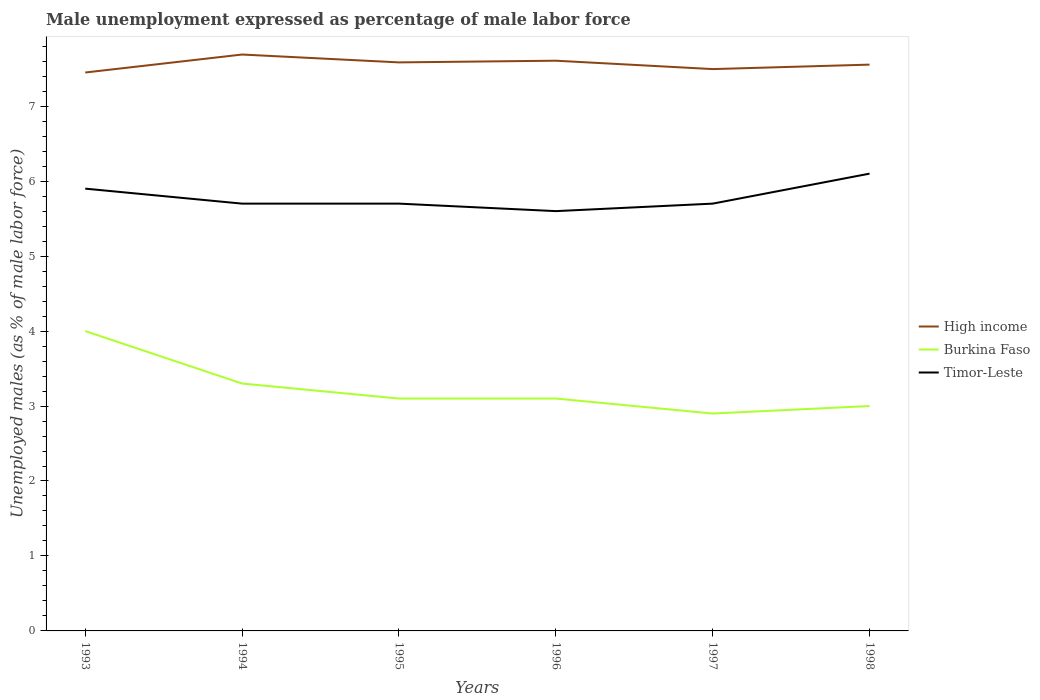How many different coloured lines are there?
Provide a short and direct response. 3. Across all years, what is the maximum unemployment in males in in High income?
Ensure brevity in your answer.  7.45. What is the total unemployment in males in in Timor-Leste in the graph?
Offer a very short reply. 0.3. What is the difference between the highest and the second highest unemployment in males in in Timor-Leste?
Provide a short and direct response. 0.5. Is the unemployment in males in in Burkina Faso strictly greater than the unemployment in males in in High income over the years?
Ensure brevity in your answer.  Yes. What is the title of the graph?
Make the answer very short. Male unemployment expressed as percentage of male labor force. Does "Australia" appear as one of the legend labels in the graph?
Provide a succinct answer. No. What is the label or title of the Y-axis?
Your answer should be very brief. Unemployed males (as % of male labor force). What is the Unemployed males (as % of male labor force) in High income in 1993?
Offer a terse response. 7.45. What is the Unemployed males (as % of male labor force) of Timor-Leste in 1993?
Your answer should be compact. 5.9. What is the Unemployed males (as % of male labor force) in High income in 1994?
Keep it short and to the point. 7.69. What is the Unemployed males (as % of male labor force) of Burkina Faso in 1994?
Give a very brief answer. 3.3. What is the Unemployed males (as % of male labor force) of Timor-Leste in 1994?
Your response must be concise. 5.7. What is the Unemployed males (as % of male labor force) of High income in 1995?
Your answer should be very brief. 7.58. What is the Unemployed males (as % of male labor force) of Burkina Faso in 1995?
Give a very brief answer. 3.1. What is the Unemployed males (as % of male labor force) of Timor-Leste in 1995?
Keep it short and to the point. 5.7. What is the Unemployed males (as % of male labor force) in High income in 1996?
Offer a very short reply. 7.61. What is the Unemployed males (as % of male labor force) in Burkina Faso in 1996?
Give a very brief answer. 3.1. What is the Unemployed males (as % of male labor force) in Timor-Leste in 1996?
Your answer should be compact. 5.6. What is the Unemployed males (as % of male labor force) of High income in 1997?
Ensure brevity in your answer.  7.49. What is the Unemployed males (as % of male labor force) in Burkina Faso in 1997?
Provide a succinct answer. 2.9. What is the Unemployed males (as % of male labor force) in Timor-Leste in 1997?
Ensure brevity in your answer.  5.7. What is the Unemployed males (as % of male labor force) of High income in 1998?
Offer a terse response. 7.55. What is the Unemployed males (as % of male labor force) in Timor-Leste in 1998?
Provide a succinct answer. 6.1. Across all years, what is the maximum Unemployed males (as % of male labor force) in High income?
Give a very brief answer. 7.69. Across all years, what is the maximum Unemployed males (as % of male labor force) in Burkina Faso?
Keep it short and to the point. 4. Across all years, what is the maximum Unemployed males (as % of male labor force) of Timor-Leste?
Keep it short and to the point. 6.1. Across all years, what is the minimum Unemployed males (as % of male labor force) in High income?
Give a very brief answer. 7.45. Across all years, what is the minimum Unemployed males (as % of male labor force) of Burkina Faso?
Keep it short and to the point. 2.9. Across all years, what is the minimum Unemployed males (as % of male labor force) of Timor-Leste?
Provide a succinct answer. 5.6. What is the total Unemployed males (as % of male labor force) in High income in the graph?
Provide a succinct answer. 45.38. What is the total Unemployed males (as % of male labor force) of Burkina Faso in the graph?
Make the answer very short. 19.4. What is the total Unemployed males (as % of male labor force) of Timor-Leste in the graph?
Your response must be concise. 34.7. What is the difference between the Unemployed males (as % of male labor force) of High income in 1993 and that in 1994?
Ensure brevity in your answer.  -0.24. What is the difference between the Unemployed males (as % of male labor force) in High income in 1993 and that in 1995?
Offer a very short reply. -0.14. What is the difference between the Unemployed males (as % of male labor force) in Burkina Faso in 1993 and that in 1995?
Offer a very short reply. 0.9. What is the difference between the Unemployed males (as % of male labor force) of Timor-Leste in 1993 and that in 1995?
Keep it short and to the point. 0.2. What is the difference between the Unemployed males (as % of male labor force) of High income in 1993 and that in 1996?
Provide a succinct answer. -0.16. What is the difference between the Unemployed males (as % of male labor force) of Burkina Faso in 1993 and that in 1996?
Give a very brief answer. 0.9. What is the difference between the Unemployed males (as % of male labor force) in High income in 1993 and that in 1997?
Your answer should be very brief. -0.05. What is the difference between the Unemployed males (as % of male labor force) of High income in 1993 and that in 1998?
Provide a succinct answer. -0.11. What is the difference between the Unemployed males (as % of male labor force) in High income in 1994 and that in 1995?
Keep it short and to the point. 0.1. What is the difference between the Unemployed males (as % of male labor force) in Timor-Leste in 1994 and that in 1995?
Keep it short and to the point. 0. What is the difference between the Unemployed males (as % of male labor force) of High income in 1994 and that in 1996?
Your answer should be compact. 0.08. What is the difference between the Unemployed males (as % of male labor force) of Burkina Faso in 1994 and that in 1996?
Your response must be concise. 0.2. What is the difference between the Unemployed males (as % of male labor force) of High income in 1994 and that in 1997?
Provide a succinct answer. 0.19. What is the difference between the Unemployed males (as % of male labor force) of Burkina Faso in 1994 and that in 1997?
Keep it short and to the point. 0.4. What is the difference between the Unemployed males (as % of male labor force) of High income in 1994 and that in 1998?
Offer a very short reply. 0.13. What is the difference between the Unemployed males (as % of male labor force) in High income in 1995 and that in 1996?
Your response must be concise. -0.02. What is the difference between the Unemployed males (as % of male labor force) in Timor-Leste in 1995 and that in 1996?
Your answer should be very brief. 0.1. What is the difference between the Unemployed males (as % of male labor force) of High income in 1995 and that in 1997?
Give a very brief answer. 0.09. What is the difference between the Unemployed males (as % of male labor force) in Timor-Leste in 1995 and that in 1997?
Offer a terse response. 0. What is the difference between the Unemployed males (as % of male labor force) in High income in 1995 and that in 1998?
Provide a short and direct response. 0.03. What is the difference between the Unemployed males (as % of male labor force) of Timor-Leste in 1995 and that in 1998?
Keep it short and to the point. -0.4. What is the difference between the Unemployed males (as % of male labor force) of High income in 1996 and that in 1997?
Your answer should be very brief. 0.11. What is the difference between the Unemployed males (as % of male labor force) in Burkina Faso in 1996 and that in 1997?
Provide a short and direct response. 0.2. What is the difference between the Unemployed males (as % of male labor force) in High income in 1996 and that in 1998?
Provide a short and direct response. 0.05. What is the difference between the Unemployed males (as % of male labor force) of Burkina Faso in 1996 and that in 1998?
Your response must be concise. 0.1. What is the difference between the Unemployed males (as % of male labor force) in High income in 1997 and that in 1998?
Your answer should be very brief. -0.06. What is the difference between the Unemployed males (as % of male labor force) of High income in 1993 and the Unemployed males (as % of male labor force) of Burkina Faso in 1994?
Your answer should be very brief. 4.15. What is the difference between the Unemployed males (as % of male labor force) in High income in 1993 and the Unemployed males (as % of male labor force) in Timor-Leste in 1994?
Ensure brevity in your answer.  1.75. What is the difference between the Unemployed males (as % of male labor force) of High income in 1993 and the Unemployed males (as % of male labor force) of Burkina Faso in 1995?
Your response must be concise. 4.35. What is the difference between the Unemployed males (as % of male labor force) of High income in 1993 and the Unemployed males (as % of male labor force) of Timor-Leste in 1995?
Keep it short and to the point. 1.75. What is the difference between the Unemployed males (as % of male labor force) in Burkina Faso in 1993 and the Unemployed males (as % of male labor force) in Timor-Leste in 1995?
Your response must be concise. -1.7. What is the difference between the Unemployed males (as % of male labor force) of High income in 1993 and the Unemployed males (as % of male labor force) of Burkina Faso in 1996?
Keep it short and to the point. 4.35. What is the difference between the Unemployed males (as % of male labor force) in High income in 1993 and the Unemployed males (as % of male labor force) in Timor-Leste in 1996?
Keep it short and to the point. 1.85. What is the difference between the Unemployed males (as % of male labor force) in Burkina Faso in 1993 and the Unemployed males (as % of male labor force) in Timor-Leste in 1996?
Give a very brief answer. -1.6. What is the difference between the Unemployed males (as % of male labor force) in High income in 1993 and the Unemployed males (as % of male labor force) in Burkina Faso in 1997?
Your answer should be compact. 4.55. What is the difference between the Unemployed males (as % of male labor force) of High income in 1993 and the Unemployed males (as % of male labor force) of Timor-Leste in 1997?
Provide a succinct answer. 1.75. What is the difference between the Unemployed males (as % of male labor force) of Burkina Faso in 1993 and the Unemployed males (as % of male labor force) of Timor-Leste in 1997?
Make the answer very short. -1.7. What is the difference between the Unemployed males (as % of male labor force) of High income in 1993 and the Unemployed males (as % of male labor force) of Burkina Faso in 1998?
Offer a terse response. 4.45. What is the difference between the Unemployed males (as % of male labor force) of High income in 1993 and the Unemployed males (as % of male labor force) of Timor-Leste in 1998?
Offer a terse response. 1.35. What is the difference between the Unemployed males (as % of male labor force) of Burkina Faso in 1993 and the Unemployed males (as % of male labor force) of Timor-Leste in 1998?
Give a very brief answer. -2.1. What is the difference between the Unemployed males (as % of male labor force) of High income in 1994 and the Unemployed males (as % of male labor force) of Burkina Faso in 1995?
Provide a succinct answer. 4.59. What is the difference between the Unemployed males (as % of male labor force) of High income in 1994 and the Unemployed males (as % of male labor force) of Timor-Leste in 1995?
Keep it short and to the point. 1.99. What is the difference between the Unemployed males (as % of male labor force) of High income in 1994 and the Unemployed males (as % of male labor force) of Burkina Faso in 1996?
Your answer should be very brief. 4.59. What is the difference between the Unemployed males (as % of male labor force) in High income in 1994 and the Unemployed males (as % of male labor force) in Timor-Leste in 1996?
Ensure brevity in your answer.  2.09. What is the difference between the Unemployed males (as % of male labor force) of High income in 1994 and the Unemployed males (as % of male labor force) of Burkina Faso in 1997?
Offer a very short reply. 4.79. What is the difference between the Unemployed males (as % of male labor force) in High income in 1994 and the Unemployed males (as % of male labor force) in Timor-Leste in 1997?
Offer a terse response. 1.99. What is the difference between the Unemployed males (as % of male labor force) of Burkina Faso in 1994 and the Unemployed males (as % of male labor force) of Timor-Leste in 1997?
Keep it short and to the point. -2.4. What is the difference between the Unemployed males (as % of male labor force) in High income in 1994 and the Unemployed males (as % of male labor force) in Burkina Faso in 1998?
Make the answer very short. 4.69. What is the difference between the Unemployed males (as % of male labor force) of High income in 1994 and the Unemployed males (as % of male labor force) of Timor-Leste in 1998?
Offer a terse response. 1.59. What is the difference between the Unemployed males (as % of male labor force) of High income in 1995 and the Unemployed males (as % of male labor force) of Burkina Faso in 1996?
Ensure brevity in your answer.  4.48. What is the difference between the Unemployed males (as % of male labor force) of High income in 1995 and the Unemployed males (as % of male labor force) of Timor-Leste in 1996?
Make the answer very short. 1.98. What is the difference between the Unemployed males (as % of male labor force) of Burkina Faso in 1995 and the Unemployed males (as % of male labor force) of Timor-Leste in 1996?
Give a very brief answer. -2.5. What is the difference between the Unemployed males (as % of male labor force) of High income in 1995 and the Unemployed males (as % of male labor force) of Burkina Faso in 1997?
Provide a succinct answer. 4.68. What is the difference between the Unemployed males (as % of male labor force) in High income in 1995 and the Unemployed males (as % of male labor force) in Timor-Leste in 1997?
Provide a succinct answer. 1.88. What is the difference between the Unemployed males (as % of male labor force) of Burkina Faso in 1995 and the Unemployed males (as % of male labor force) of Timor-Leste in 1997?
Your response must be concise. -2.6. What is the difference between the Unemployed males (as % of male labor force) in High income in 1995 and the Unemployed males (as % of male labor force) in Burkina Faso in 1998?
Make the answer very short. 4.58. What is the difference between the Unemployed males (as % of male labor force) of High income in 1995 and the Unemployed males (as % of male labor force) of Timor-Leste in 1998?
Your answer should be very brief. 1.48. What is the difference between the Unemployed males (as % of male labor force) in Burkina Faso in 1995 and the Unemployed males (as % of male labor force) in Timor-Leste in 1998?
Your answer should be compact. -3. What is the difference between the Unemployed males (as % of male labor force) of High income in 1996 and the Unemployed males (as % of male labor force) of Burkina Faso in 1997?
Make the answer very short. 4.71. What is the difference between the Unemployed males (as % of male labor force) of High income in 1996 and the Unemployed males (as % of male labor force) of Timor-Leste in 1997?
Provide a succinct answer. 1.91. What is the difference between the Unemployed males (as % of male labor force) in High income in 1996 and the Unemployed males (as % of male labor force) in Burkina Faso in 1998?
Make the answer very short. 4.61. What is the difference between the Unemployed males (as % of male labor force) of High income in 1996 and the Unemployed males (as % of male labor force) of Timor-Leste in 1998?
Your response must be concise. 1.51. What is the difference between the Unemployed males (as % of male labor force) of High income in 1997 and the Unemployed males (as % of male labor force) of Burkina Faso in 1998?
Provide a short and direct response. 4.49. What is the difference between the Unemployed males (as % of male labor force) in High income in 1997 and the Unemployed males (as % of male labor force) in Timor-Leste in 1998?
Give a very brief answer. 1.39. What is the difference between the Unemployed males (as % of male labor force) of Burkina Faso in 1997 and the Unemployed males (as % of male labor force) of Timor-Leste in 1998?
Ensure brevity in your answer.  -3.2. What is the average Unemployed males (as % of male labor force) of High income per year?
Make the answer very short. 7.56. What is the average Unemployed males (as % of male labor force) in Burkina Faso per year?
Make the answer very short. 3.23. What is the average Unemployed males (as % of male labor force) in Timor-Leste per year?
Keep it short and to the point. 5.78. In the year 1993, what is the difference between the Unemployed males (as % of male labor force) in High income and Unemployed males (as % of male labor force) in Burkina Faso?
Keep it short and to the point. 3.45. In the year 1993, what is the difference between the Unemployed males (as % of male labor force) of High income and Unemployed males (as % of male labor force) of Timor-Leste?
Your answer should be compact. 1.55. In the year 1993, what is the difference between the Unemployed males (as % of male labor force) of Burkina Faso and Unemployed males (as % of male labor force) of Timor-Leste?
Make the answer very short. -1.9. In the year 1994, what is the difference between the Unemployed males (as % of male labor force) in High income and Unemployed males (as % of male labor force) in Burkina Faso?
Make the answer very short. 4.39. In the year 1994, what is the difference between the Unemployed males (as % of male labor force) of High income and Unemployed males (as % of male labor force) of Timor-Leste?
Keep it short and to the point. 1.99. In the year 1994, what is the difference between the Unemployed males (as % of male labor force) in Burkina Faso and Unemployed males (as % of male labor force) in Timor-Leste?
Provide a succinct answer. -2.4. In the year 1995, what is the difference between the Unemployed males (as % of male labor force) in High income and Unemployed males (as % of male labor force) in Burkina Faso?
Keep it short and to the point. 4.48. In the year 1995, what is the difference between the Unemployed males (as % of male labor force) in High income and Unemployed males (as % of male labor force) in Timor-Leste?
Make the answer very short. 1.88. In the year 1995, what is the difference between the Unemployed males (as % of male labor force) in Burkina Faso and Unemployed males (as % of male labor force) in Timor-Leste?
Provide a succinct answer. -2.6. In the year 1996, what is the difference between the Unemployed males (as % of male labor force) of High income and Unemployed males (as % of male labor force) of Burkina Faso?
Provide a short and direct response. 4.51. In the year 1996, what is the difference between the Unemployed males (as % of male labor force) of High income and Unemployed males (as % of male labor force) of Timor-Leste?
Ensure brevity in your answer.  2.01. In the year 1996, what is the difference between the Unemployed males (as % of male labor force) in Burkina Faso and Unemployed males (as % of male labor force) in Timor-Leste?
Your response must be concise. -2.5. In the year 1997, what is the difference between the Unemployed males (as % of male labor force) in High income and Unemployed males (as % of male labor force) in Burkina Faso?
Provide a succinct answer. 4.59. In the year 1997, what is the difference between the Unemployed males (as % of male labor force) of High income and Unemployed males (as % of male labor force) of Timor-Leste?
Give a very brief answer. 1.79. In the year 1997, what is the difference between the Unemployed males (as % of male labor force) of Burkina Faso and Unemployed males (as % of male labor force) of Timor-Leste?
Provide a succinct answer. -2.8. In the year 1998, what is the difference between the Unemployed males (as % of male labor force) of High income and Unemployed males (as % of male labor force) of Burkina Faso?
Your response must be concise. 4.55. In the year 1998, what is the difference between the Unemployed males (as % of male labor force) of High income and Unemployed males (as % of male labor force) of Timor-Leste?
Keep it short and to the point. 1.45. In the year 1998, what is the difference between the Unemployed males (as % of male labor force) of Burkina Faso and Unemployed males (as % of male labor force) of Timor-Leste?
Provide a short and direct response. -3.1. What is the ratio of the Unemployed males (as % of male labor force) of High income in 1993 to that in 1994?
Keep it short and to the point. 0.97. What is the ratio of the Unemployed males (as % of male labor force) of Burkina Faso in 1993 to that in 1994?
Provide a short and direct response. 1.21. What is the ratio of the Unemployed males (as % of male labor force) of Timor-Leste in 1993 to that in 1994?
Your response must be concise. 1.04. What is the ratio of the Unemployed males (as % of male labor force) of High income in 1993 to that in 1995?
Offer a terse response. 0.98. What is the ratio of the Unemployed males (as % of male labor force) of Burkina Faso in 1993 to that in 1995?
Your answer should be very brief. 1.29. What is the ratio of the Unemployed males (as % of male labor force) of Timor-Leste in 1993 to that in 1995?
Your answer should be compact. 1.04. What is the ratio of the Unemployed males (as % of male labor force) of High income in 1993 to that in 1996?
Offer a very short reply. 0.98. What is the ratio of the Unemployed males (as % of male labor force) of Burkina Faso in 1993 to that in 1996?
Give a very brief answer. 1.29. What is the ratio of the Unemployed males (as % of male labor force) of Timor-Leste in 1993 to that in 1996?
Your response must be concise. 1.05. What is the ratio of the Unemployed males (as % of male labor force) in Burkina Faso in 1993 to that in 1997?
Your response must be concise. 1.38. What is the ratio of the Unemployed males (as % of male labor force) in Timor-Leste in 1993 to that in 1997?
Provide a short and direct response. 1.04. What is the ratio of the Unemployed males (as % of male labor force) of High income in 1993 to that in 1998?
Give a very brief answer. 0.99. What is the ratio of the Unemployed males (as % of male labor force) of Burkina Faso in 1993 to that in 1998?
Offer a very short reply. 1.33. What is the ratio of the Unemployed males (as % of male labor force) of Timor-Leste in 1993 to that in 1998?
Provide a succinct answer. 0.97. What is the ratio of the Unemployed males (as % of male labor force) in High income in 1994 to that in 1995?
Make the answer very short. 1.01. What is the ratio of the Unemployed males (as % of male labor force) of Burkina Faso in 1994 to that in 1995?
Give a very brief answer. 1.06. What is the ratio of the Unemployed males (as % of male labor force) in High income in 1994 to that in 1996?
Your answer should be very brief. 1.01. What is the ratio of the Unemployed males (as % of male labor force) in Burkina Faso in 1994 to that in 1996?
Your response must be concise. 1.06. What is the ratio of the Unemployed males (as % of male labor force) of Timor-Leste in 1994 to that in 1996?
Your answer should be compact. 1.02. What is the ratio of the Unemployed males (as % of male labor force) in High income in 1994 to that in 1997?
Keep it short and to the point. 1.03. What is the ratio of the Unemployed males (as % of male labor force) of Burkina Faso in 1994 to that in 1997?
Give a very brief answer. 1.14. What is the ratio of the Unemployed males (as % of male labor force) of Timor-Leste in 1994 to that in 1997?
Make the answer very short. 1. What is the ratio of the Unemployed males (as % of male labor force) in High income in 1994 to that in 1998?
Offer a very short reply. 1.02. What is the ratio of the Unemployed males (as % of male labor force) of Burkina Faso in 1994 to that in 1998?
Offer a very short reply. 1.1. What is the ratio of the Unemployed males (as % of male labor force) in Timor-Leste in 1994 to that in 1998?
Provide a short and direct response. 0.93. What is the ratio of the Unemployed males (as % of male labor force) of Timor-Leste in 1995 to that in 1996?
Your answer should be compact. 1.02. What is the ratio of the Unemployed males (as % of male labor force) in High income in 1995 to that in 1997?
Ensure brevity in your answer.  1.01. What is the ratio of the Unemployed males (as % of male labor force) in Burkina Faso in 1995 to that in 1997?
Provide a short and direct response. 1.07. What is the ratio of the Unemployed males (as % of male labor force) of Timor-Leste in 1995 to that in 1997?
Keep it short and to the point. 1. What is the ratio of the Unemployed males (as % of male labor force) in Timor-Leste in 1995 to that in 1998?
Give a very brief answer. 0.93. What is the ratio of the Unemployed males (as % of male labor force) in High income in 1996 to that in 1997?
Offer a very short reply. 1.01. What is the ratio of the Unemployed males (as % of male labor force) of Burkina Faso in 1996 to that in 1997?
Make the answer very short. 1.07. What is the ratio of the Unemployed males (as % of male labor force) in Timor-Leste in 1996 to that in 1997?
Give a very brief answer. 0.98. What is the ratio of the Unemployed males (as % of male labor force) of High income in 1996 to that in 1998?
Provide a short and direct response. 1.01. What is the ratio of the Unemployed males (as % of male labor force) of Timor-Leste in 1996 to that in 1998?
Give a very brief answer. 0.92. What is the ratio of the Unemployed males (as % of male labor force) in High income in 1997 to that in 1998?
Ensure brevity in your answer.  0.99. What is the ratio of the Unemployed males (as % of male labor force) of Burkina Faso in 1997 to that in 1998?
Provide a short and direct response. 0.97. What is the ratio of the Unemployed males (as % of male labor force) of Timor-Leste in 1997 to that in 1998?
Offer a terse response. 0.93. What is the difference between the highest and the second highest Unemployed males (as % of male labor force) of High income?
Ensure brevity in your answer.  0.08. What is the difference between the highest and the second highest Unemployed males (as % of male labor force) of Timor-Leste?
Your answer should be compact. 0.2. What is the difference between the highest and the lowest Unemployed males (as % of male labor force) in High income?
Your answer should be very brief. 0.24. 